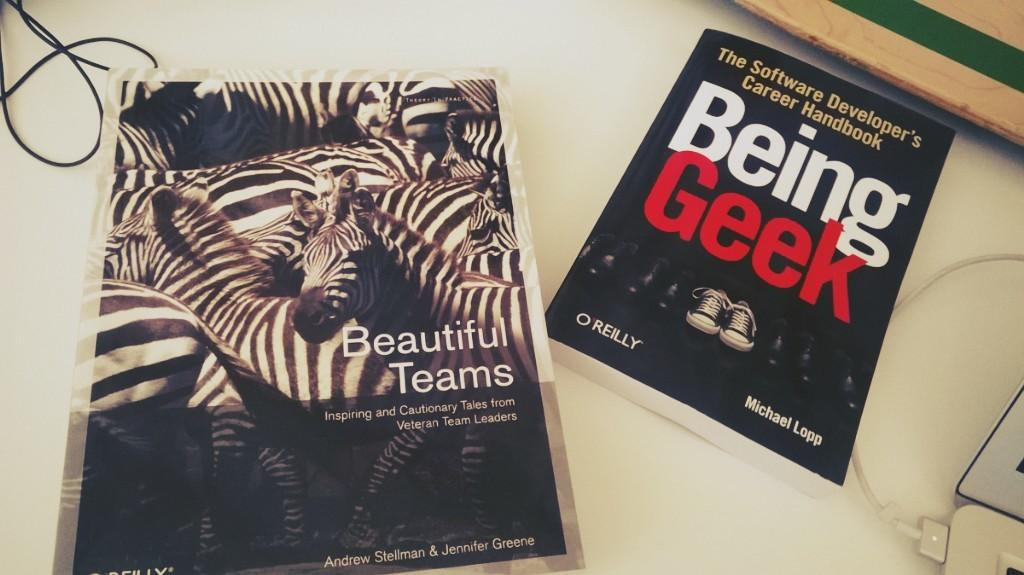<image>
Describe the image concisely. the words Being Geek are in the book 